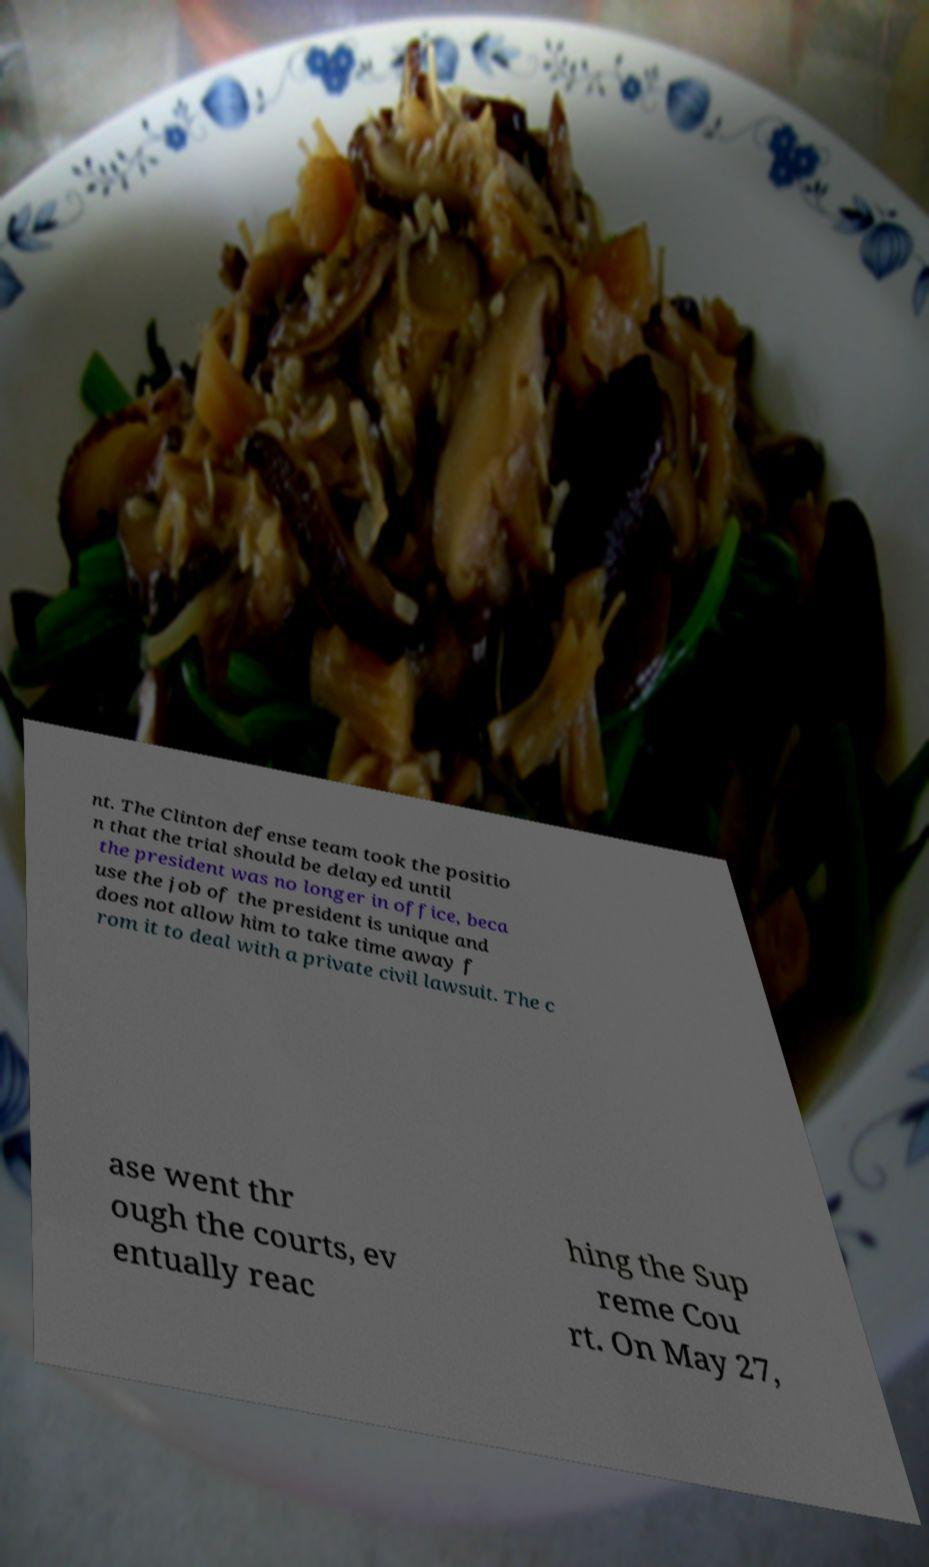Could you extract and type out the text from this image? nt. The Clinton defense team took the positio n that the trial should be delayed until the president was no longer in office, beca use the job of the president is unique and does not allow him to take time away f rom it to deal with a private civil lawsuit. The c ase went thr ough the courts, ev entually reac hing the Sup reme Cou rt. On May 27, 